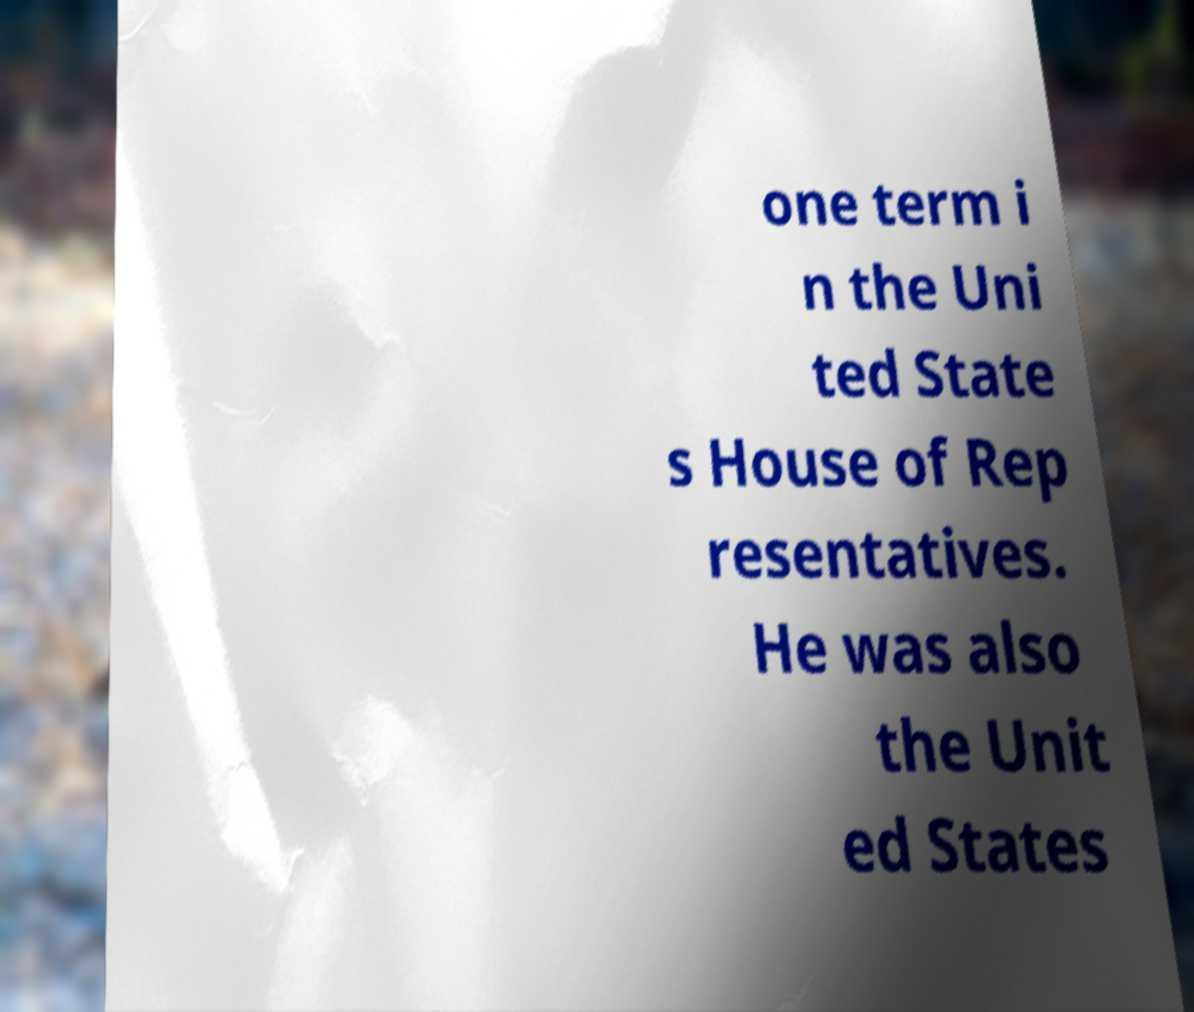Can you accurately transcribe the text from the provided image for me? one term i n the Uni ted State s House of Rep resentatives. He was also the Unit ed States 